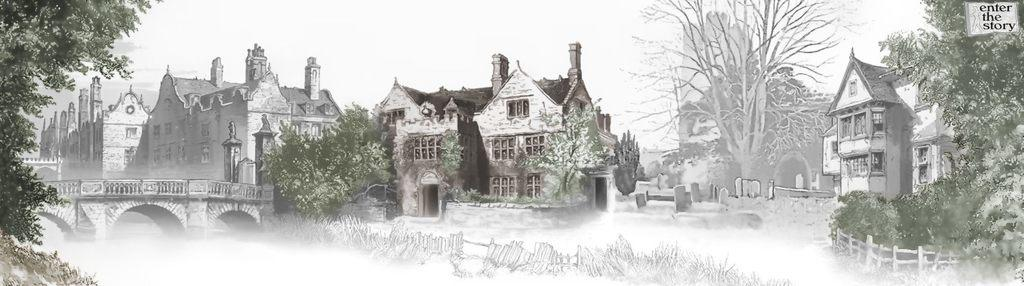What is the main subject of the image? The main subject of the image is a poster. What types of structures are depicted on the poster? The poster contains images of buildings, trees, and a bridge. What part of the natural environment is visible on the poster? The sky is visible on the poster. What type of love can be seen in the image? There is no love present in the image, as it features a poster with images of buildings, trees, and a bridge. Can you tell me how many pans are visible in the image? There are no pans present in the image. 